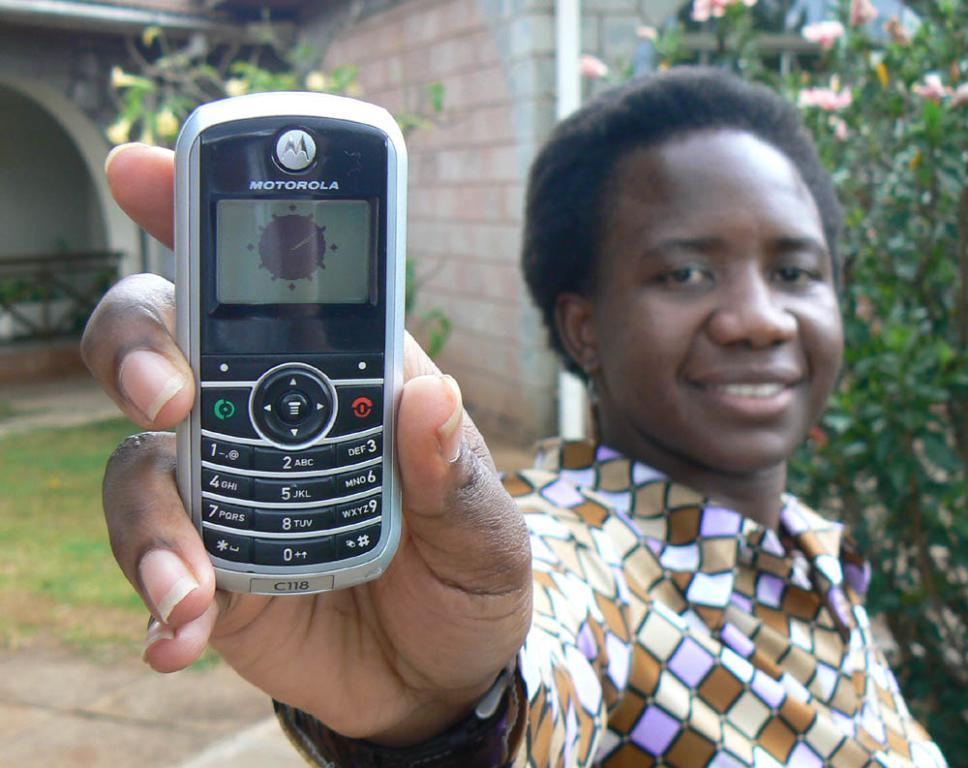Who is present in the image? There is a woman in the image. What is the woman holding in her hand? The woman is holding a mobile in her hand. What type of natural environment can be seen in the image? There are trees visible in the image. What type of structure is present in the image? There is a building in the image. What is the ground covered with in the image? There is grass on the ground in the image. What is the woman's digestion process like in the image? There is no information about the woman's digestion process in the image. 